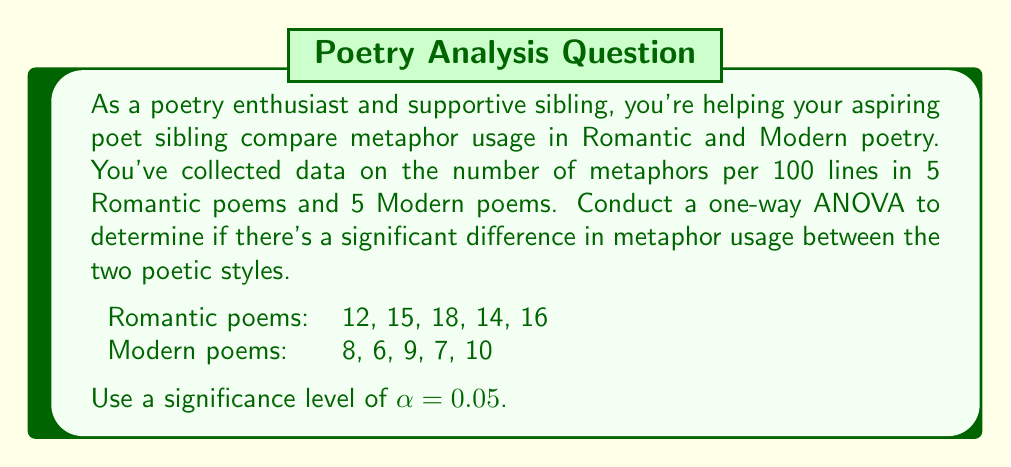What is the answer to this math problem? To conduct a one-way ANOVA, we'll follow these steps:

1. Calculate the sum of squares between groups (SSB) and within groups (SSW).
2. Calculate the degrees of freedom for between groups (dfB) and within groups (dfW).
3. Calculate the mean square between groups (MSB) and within groups (MSW).
4. Calculate the F-statistic.
5. Compare the F-statistic to the critical F-value.

Step 1: Calculate SSB and SSW

First, we need to calculate the grand mean:
$$\bar{X} = \frac{12 + 15 + 18 + 14 + 16 + 8 + 6 + 9 + 7 + 10}{10} = 11.5$$

Now, calculate the group means:
$$\bar{X}_{\text{Romantic}} = \frac{12 + 15 + 18 + 14 + 16}{5} = 15$$
$$\bar{X}_{\text{Modern}} = \frac{8 + 6 + 9 + 7 + 10}{5} = 8$$

Calculate SSB:
$$SSB = 5(15 - 11.5)^2 + 5(8 - 11.5)^2 = 122.5$$

Calculate SSW:
$$SSW_{\text{Romantic}} = (12 - 15)^2 + (15 - 15)^2 + (18 - 15)^2 + (14 - 15)^2 + (16 - 15)^2 = 22$$
$$SSW_{\text{Modern}} = (8 - 8)^2 + (6 - 8)^2 + (9 - 8)^2 + (7 - 8)^2 + (10 - 8)^2 = 14$$
$$SSW = SSW_{\text{Romantic}} + SSW_{\text{Modern}} = 36$$

Step 2: Calculate degrees of freedom

$$df_B = k - 1 = 2 - 1 = 1$$
$$df_W = N - k = 10 - 2 = 8$$

where k is the number of groups and N is the total number of observations.

Step 3: Calculate mean squares

$$MSB = \frac{SSB}{df_B} = \frac{122.5}{1} = 122.5$$
$$MSW = \frac{SSW}{df_W} = \frac{36}{8} = 4.5$$

Step 4: Calculate F-statistic

$$F = \frac{MSB}{MSW} = \frac{122.5}{4.5} = 27.22$$

Step 5: Compare F-statistic to critical F-value

The critical F-value for $\alpha = 0.05$, $df_B = 1$, and $df_W = 8$ is approximately 5.32.

Since our calculated F-statistic (27.22) is greater than the critical F-value (5.32), we reject the null hypothesis.
Answer: The one-way ANOVA results show a significant difference in metaphor usage between Romantic and Modern poetry (F(1, 8) = 27.22, p < 0.05). We reject the null hypothesis and conclude that there is a statistically significant difference in the number of metaphors used per 100 lines between Romantic and Modern poems. 